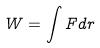Convert formula to latex. <formula><loc_0><loc_0><loc_500><loc_500>W = \int F d r</formula> 